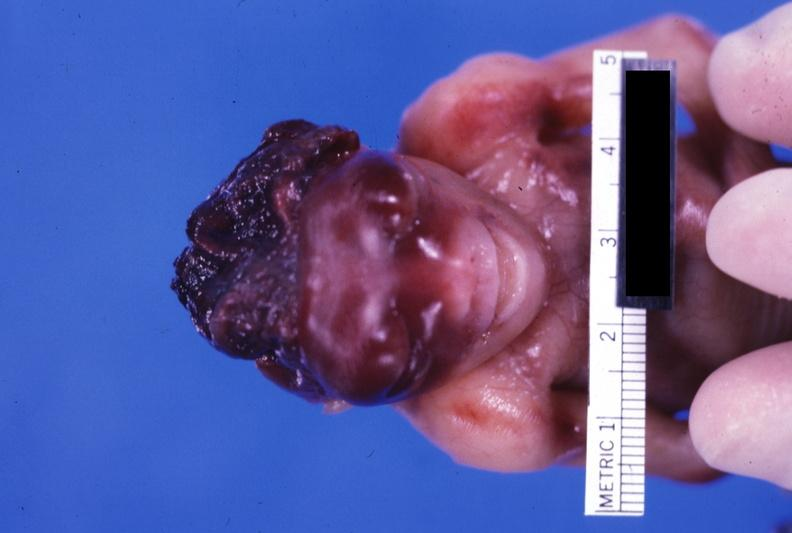s anencephaly present?
Answer the question using a single word or phrase. Yes 